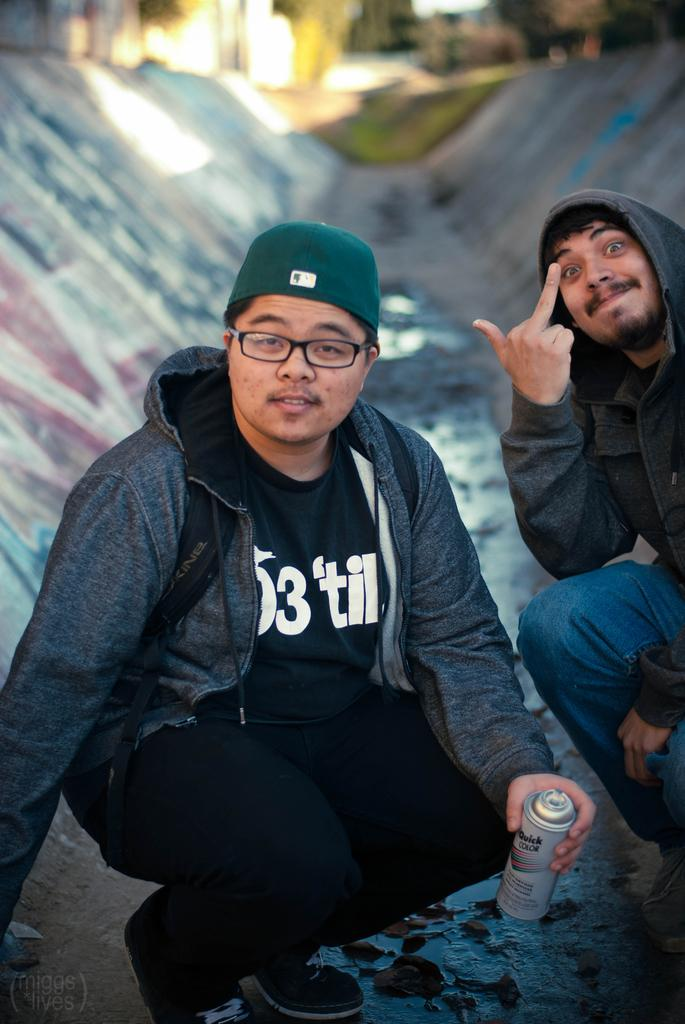How many people are in the image? There are two men in the image. What is one of the men holding? One man is holding a spray. On which side of the image is the man holding the spray? The man holding the spray is on the left side of the image. What can be observed about the background of the image? The background of the image is blurry. What type of clothing is the man holding the spray wearing? The man holding the spray is wearing a cap. Can you see a nest in the image? There is no nest present in the image. Are the two men in the image brothers? The relationship between the two men in the image is not mentioned, so we cannot determine if they are brothers. 